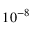<formula> <loc_0><loc_0><loc_500><loc_500>1 0 ^ { - 8 }</formula> 